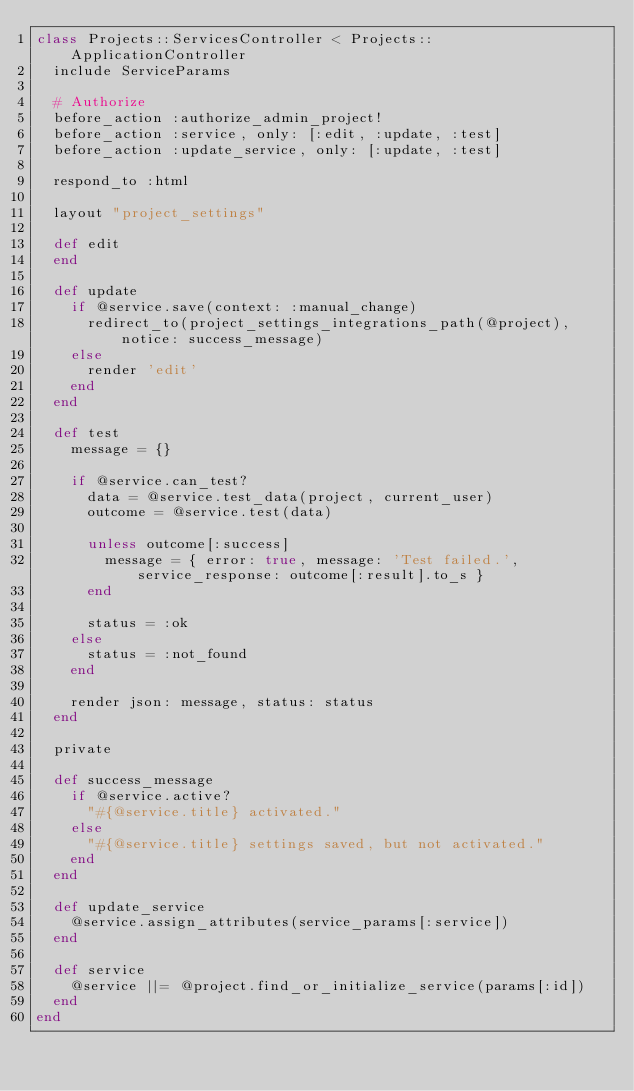Convert code to text. <code><loc_0><loc_0><loc_500><loc_500><_Ruby_>class Projects::ServicesController < Projects::ApplicationController
  include ServiceParams

  # Authorize
  before_action :authorize_admin_project!
  before_action :service, only: [:edit, :update, :test]
  before_action :update_service, only: [:update, :test]

  respond_to :html

  layout "project_settings"

  def edit
  end

  def update
    if @service.save(context: :manual_change)
      redirect_to(project_settings_integrations_path(@project), notice: success_message)
    else
      render 'edit'
    end
  end

  def test
    message = {}

    if @service.can_test?
      data = @service.test_data(project, current_user)
      outcome = @service.test(data)

      unless outcome[:success]
        message = { error: true, message: 'Test failed.', service_response: outcome[:result].to_s }
      end

      status = :ok
    else
      status = :not_found
    end

    render json: message, status: status
  end

  private

  def success_message
    if @service.active?
      "#{@service.title} activated."
    else
      "#{@service.title} settings saved, but not activated."
    end
  end

  def update_service
    @service.assign_attributes(service_params[:service])
  end

  def service
    @service ||= @project.find_or_initialize_service(params[:id])
  end
end
</code> 